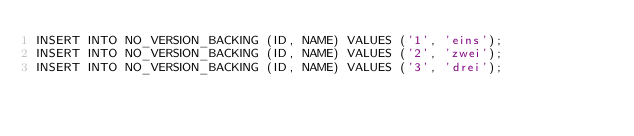<code> <loc_0><loc_0><loc_500><loc_500><_SQL_>INSERT INTO NO_VERSION_BACKING (ID, NAME) VALUES ('1', 'eins');
INSERT INTO NO_VERSION_BACKING (ID, NAME) VALUES ('2', 'zwei');
INSERT INTO NO_VERSION_BACKING (ID, NAME) VALUES ('3', 'drei');
</code> 